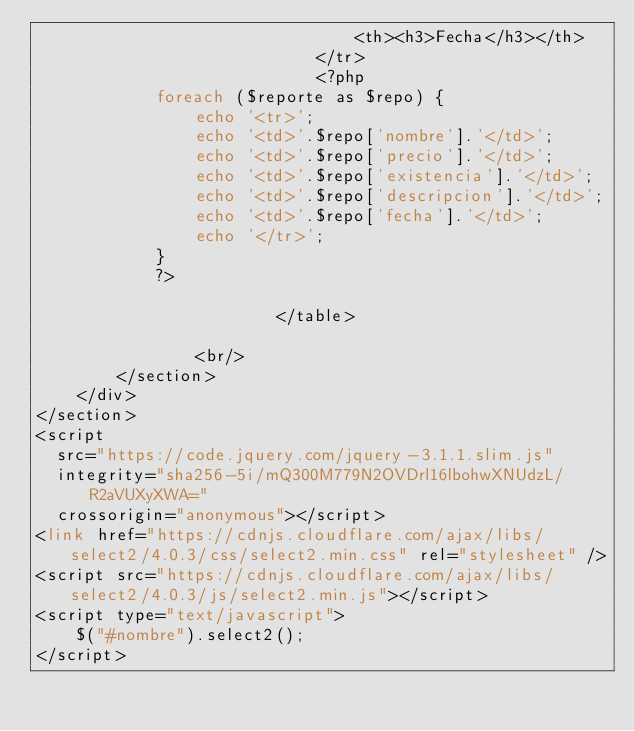<code> <loc_0><loc_0><loc_500><loc_500><_PHP_>                                <th><h3>Fecha</h3></th>
                            </tr>
                            <?php
            foreach ($reporte as $repo) {
                echo '<tr>';
                echo '<td>'.$repo['nombre'].'</td>';
                echo '<td>'.$repo['precio'].'</td>';
                echo '<td>'.$repo['existencia'].'</td>';
                echo '<td>'.$repo['descripcion'].'</td>';
                echo '<td>'.$repo['fecha'].'</td>';
                echo '</tr>';
            }
            ?>

                        </table>               
                               
                <br/>
        </section>
    </div>
</section>
<script
  src="https://code.jquery.com/jquery-3.1.1.slim.js"
  integrity="sha256-5i/mQ300M779N2OVDrl16lbohwXNUdzL/R2aVUXyXWA="
  crossorigin="anonymous"></script>
<link href="https://cdnjs.cloudflare.com/ajax/libs/select2/4.0.3/css/select2.min.css" rel="stylesheet" />
<script src="https://cdnjs.cloudflare.com/ajax/libs/select2/4.0.3/js/select2.min.js"></script>
<script type="text/javascript">
    $("#nombre").select2();
</script>
</code> 